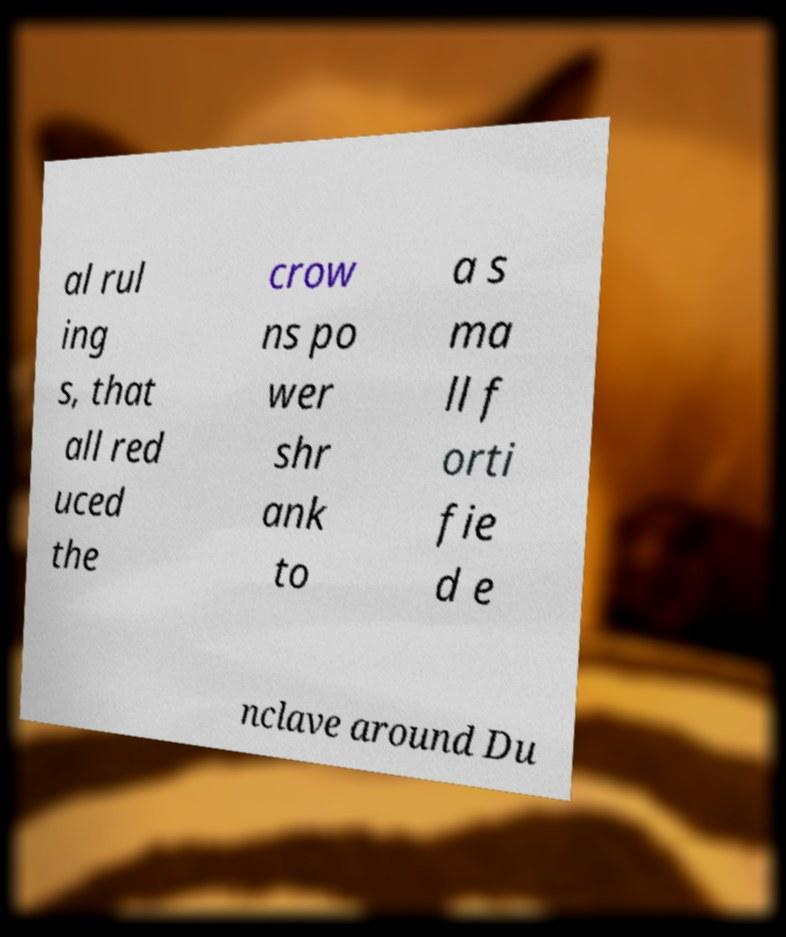I need the written content from this picture converted into text. Can you do that? al rul ing s, that all red uced the crow ns po wer shr ank to a s ma ll f orti fie d e nclave around Du 